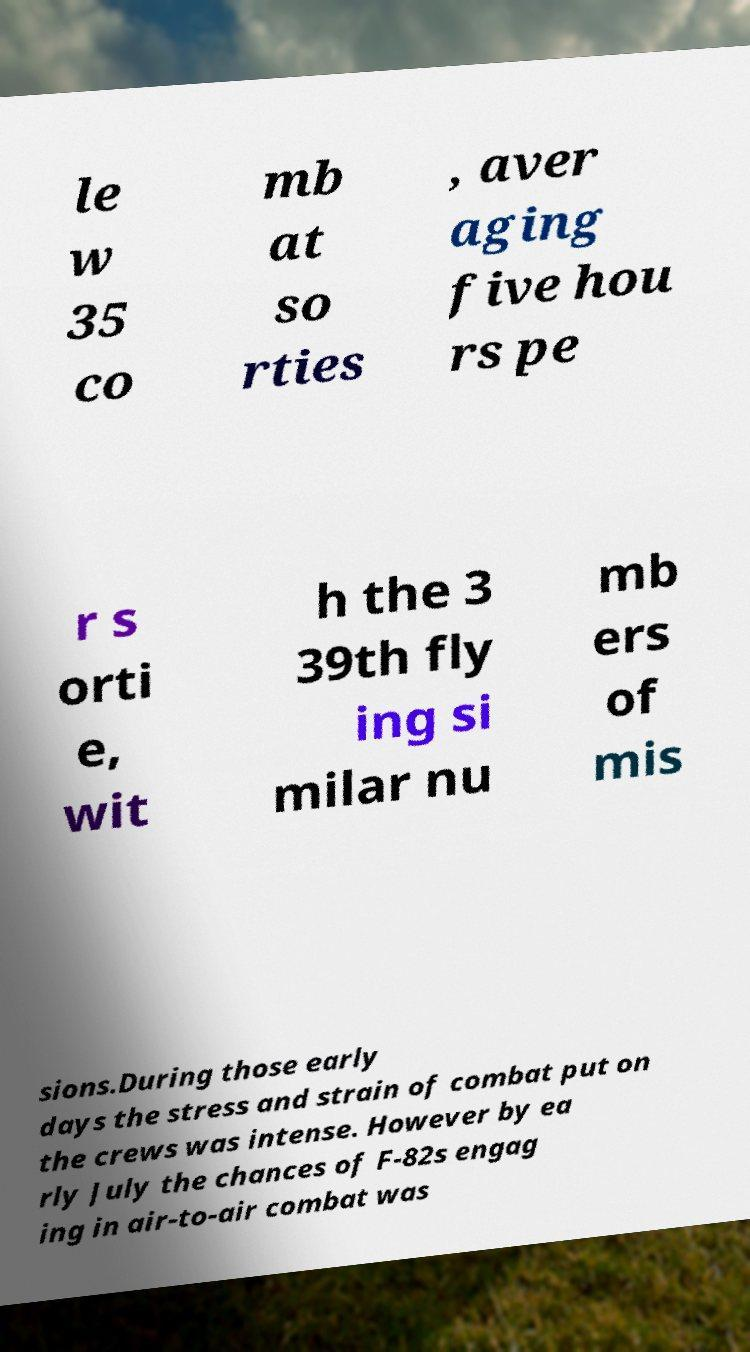Please read and relay the text visible in this image. What does it say? le w 35 co mb at so rties , aver aging five hou rs pe r s orti e, wit h the 3 39th fly ing si milar nu mb ers of mis sions.During those early days the stress and strain of combat put on the crews was intense. However by ea rly July the chances of F-82s engag ing in air-to-air combat was 